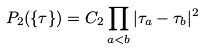Convert formula to latex. <formula><loc_0><loc_0><loc_500><loc_500>P _ { 2 } ( \{ \tau \} ) = C _ { 2 } \prod _ { a < b } | \tau _ { a } - \tau _ { b } | ^ { 2 }</formula> 